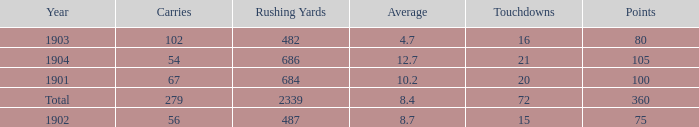How many carries have an average under 8.7 and touchdowns of 72? 1.0. 